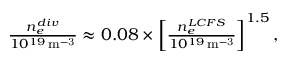<formula> <loc_0><loc_0><loc_500><loc_500>\begin{array} { r } { \frac { n _ { e } ^ { d i v } } { 1 0 ^ { 1 9 } \, m ^ { - 3 } } \approx 0 . 0 8 \times \left [ \frac { n _ { e } ^ { L C F S } } { 1 0 ^ { 1 9 } \, m ^ { - 3 } } \right ] ^ { 1 . 5 } , } \end{array}</formula> 